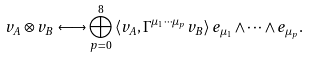<formula> <loc_0><loc_0><loc_500><loc_500>v _ { A } \otimes v _ { B } \longleftrightarrow \bigoplus _ { p = 0 } ^ { 8 } \, \langle v _ { A } , \Gamma ^ { \mu _ { 1 } \cdots \mu _ { p } } v _ { B } \rangle \, e _ { \mu _ { 1 } } \wedge \cdots \wedge e _ { \mu _ { p } } .</formula> 